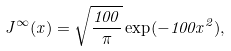<formula> <loc_0><loc_0><loc_500><loc_500>J ^ { \infty } ( x ) = \sqrt { \frac { 1 0 0 } { \pi } } \exp ( - 1 0 0 x ^ { 2 } ) ,</formula> 